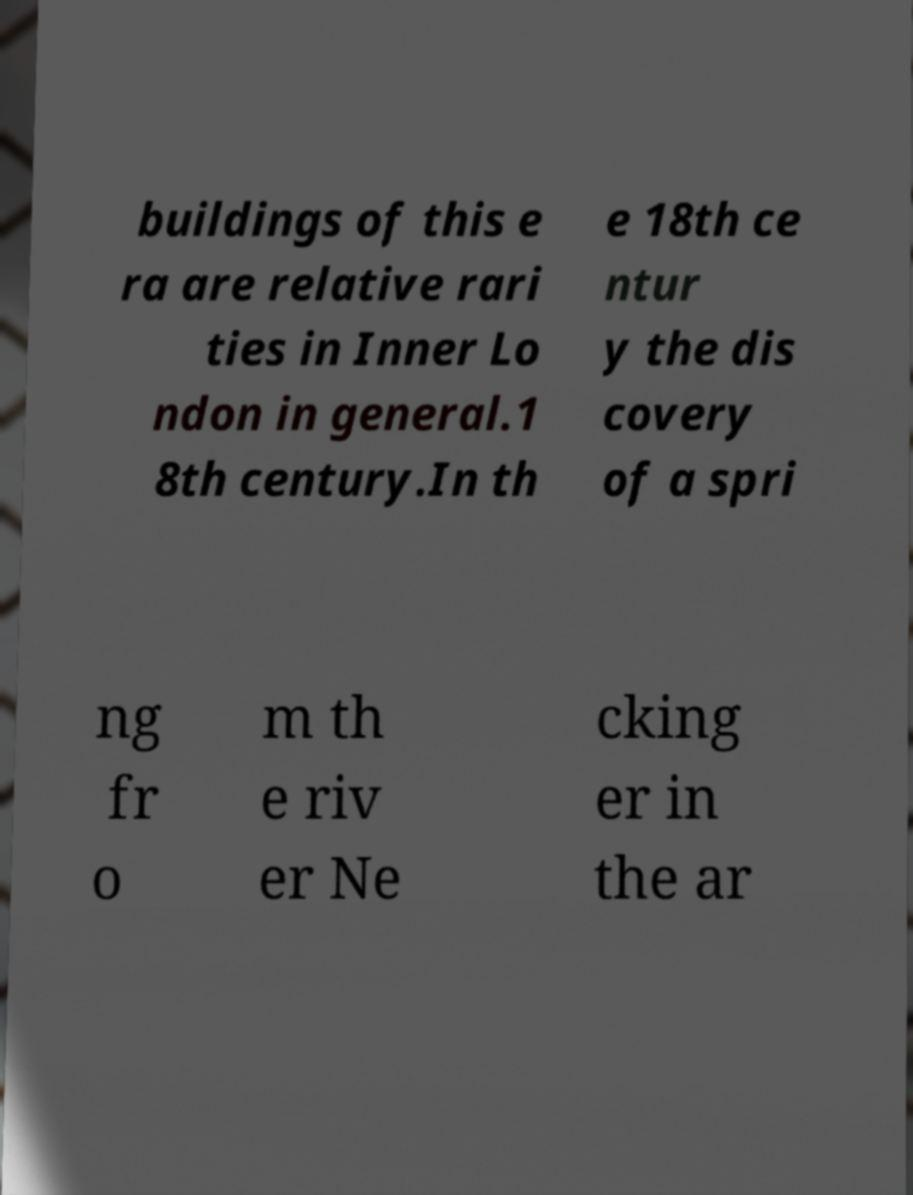There's text embedded in this image that I need extracted. Can you transcribe it verbatim? buildings of this e ra are relative rari ties in Inner Lo ndon in general.1 8th century.In th e 18th ce ntur y the dis covery of a spri ng fr o m th e riv er Ne cking er in the ar 